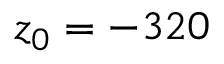<formula> <loc_0><loc_0><loc_500><loc_500>z _ { 0 } = - 3 2 0</formula> 